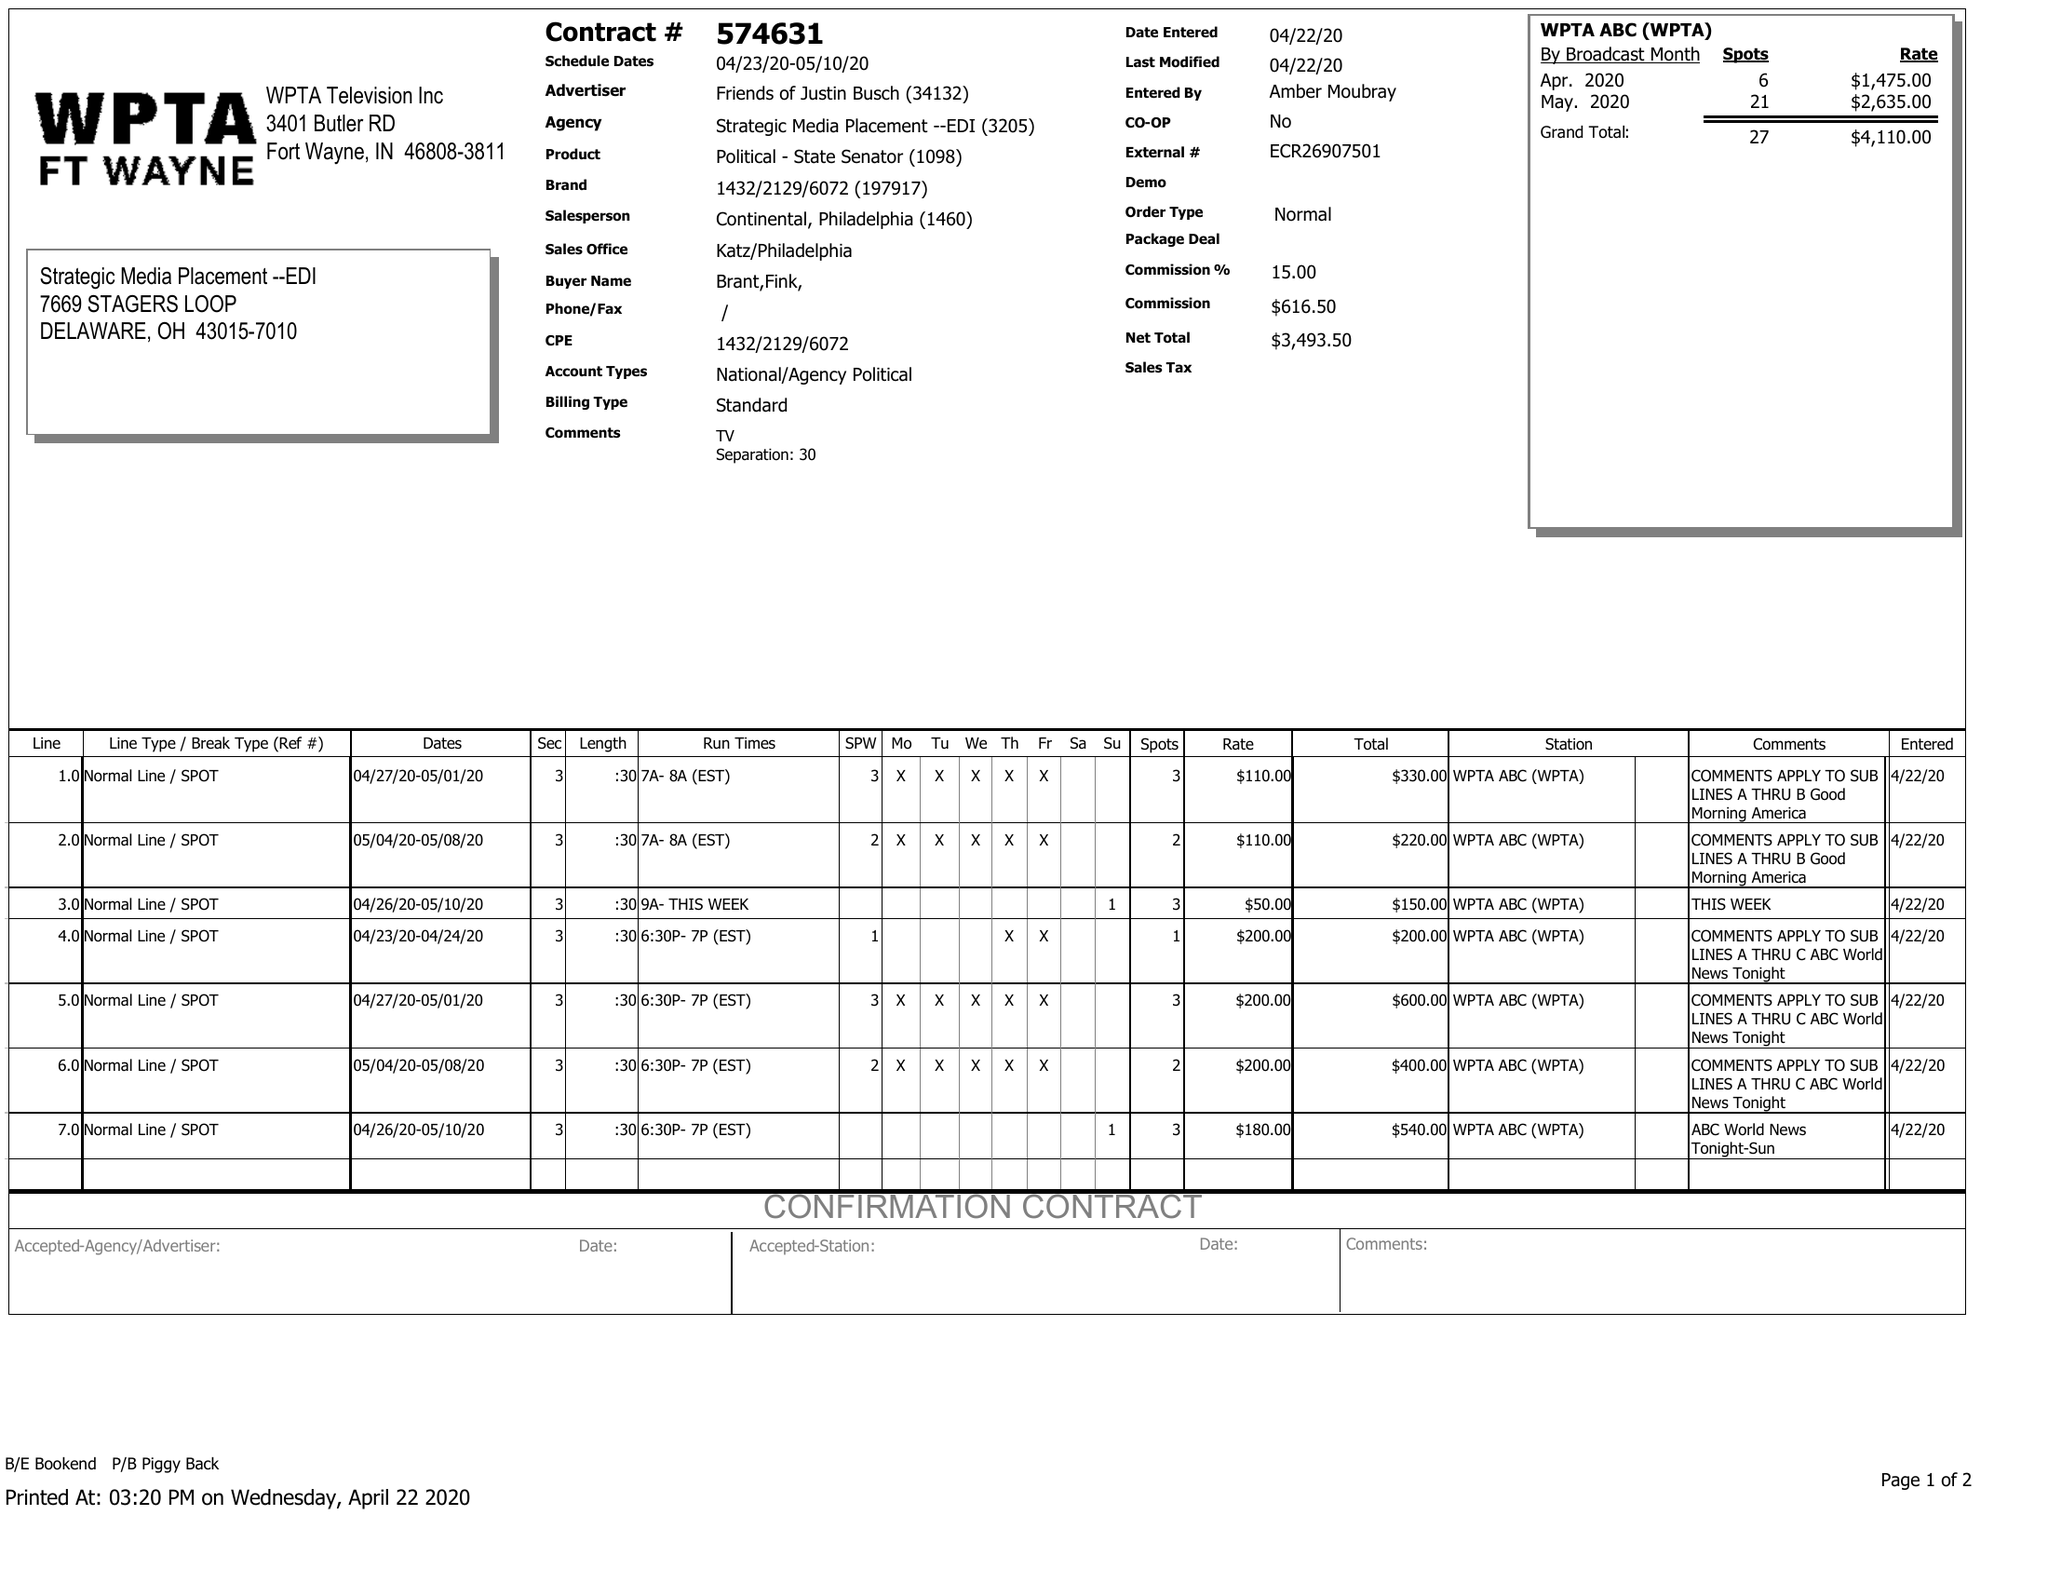What is the value for the gross_amount?
Answer the question using a single word or phrase. 4110.00 